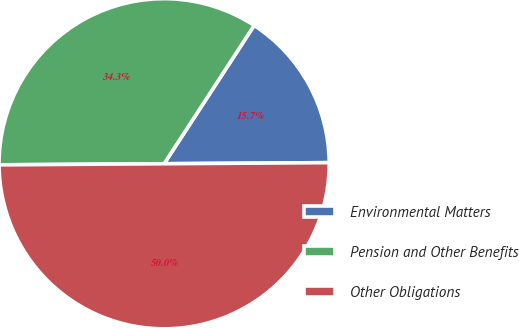<chart> <loc_0><loc_0><loc_500><loc_500><pie_chart><fcel>Environmental Matters<fcel>Pension and Other Benefits<fcel>Other Obligations<nl><fcel>15.71%<fcel>34.29%<fcel>50.0%<nl></chart> 